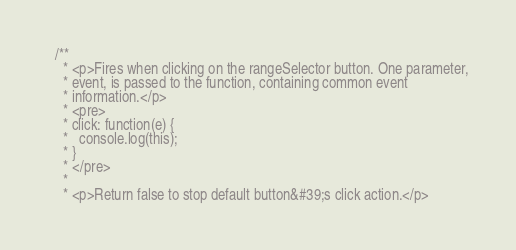<code> <loc_0><loc_0><loc_500><loc_500><_Scala_>
  /**
    * <p>Fires when clicking on the rangeSelector button. One parameter,
    * event, is passed to the function, containing common event
    * information.</p>
    * <pre>
    * click: function(e) {
    *   console.log(this);
    * }
    * </pre>
    * 
    * <p>Return false to stop default button&#39;s click action.</p></code> 